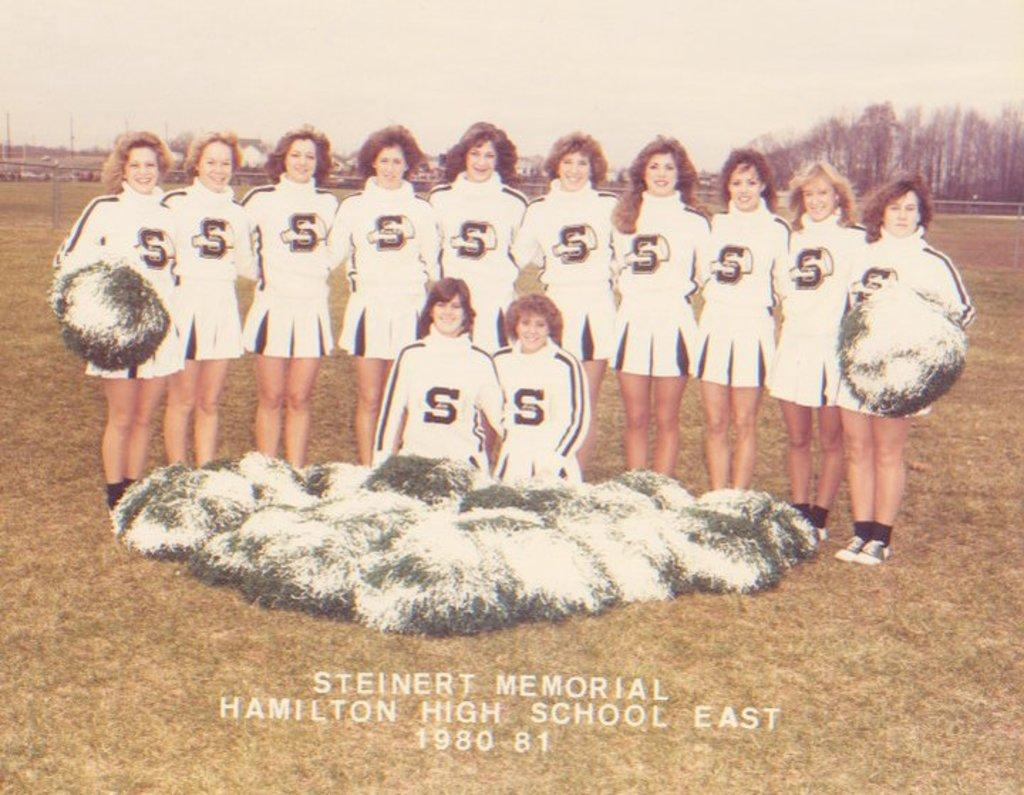<image>
Describe the image concisely. Steinert Memorial Hamilton High School had a girls cheerleading team during the early 1980s. 